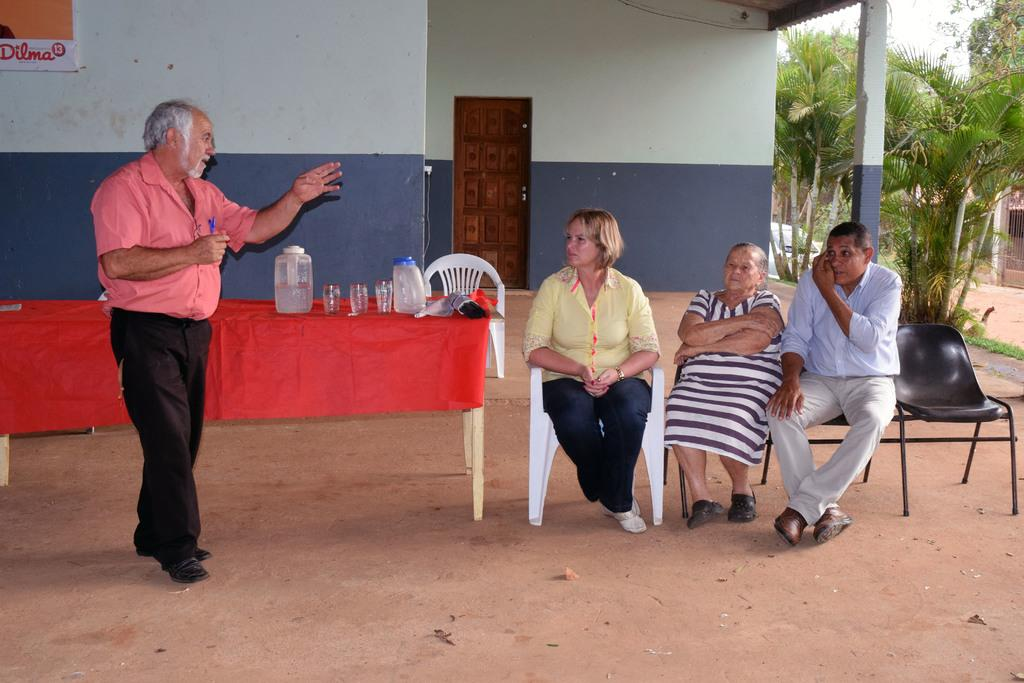What type of structure can be seen in the image? There is a wall in the image. Is there any entrance visible in the image? Yes, there is a door in the image. What can be seen in the background of the image? There are trees in the image. What type of furniture is present in the image? There are tables and chairs in the image. What are the people in the image doing? There are people sitting on the chairs. What type of pie is being served on the table in the image? There is no pie present in the image; it features a wall, a door, trees, tables, chairs, and people sitting on the chairs. What type of creature can be seen interacting with the people sitting on the chairs? There is no creature present in the image; it only features people sitting on the chairs. 